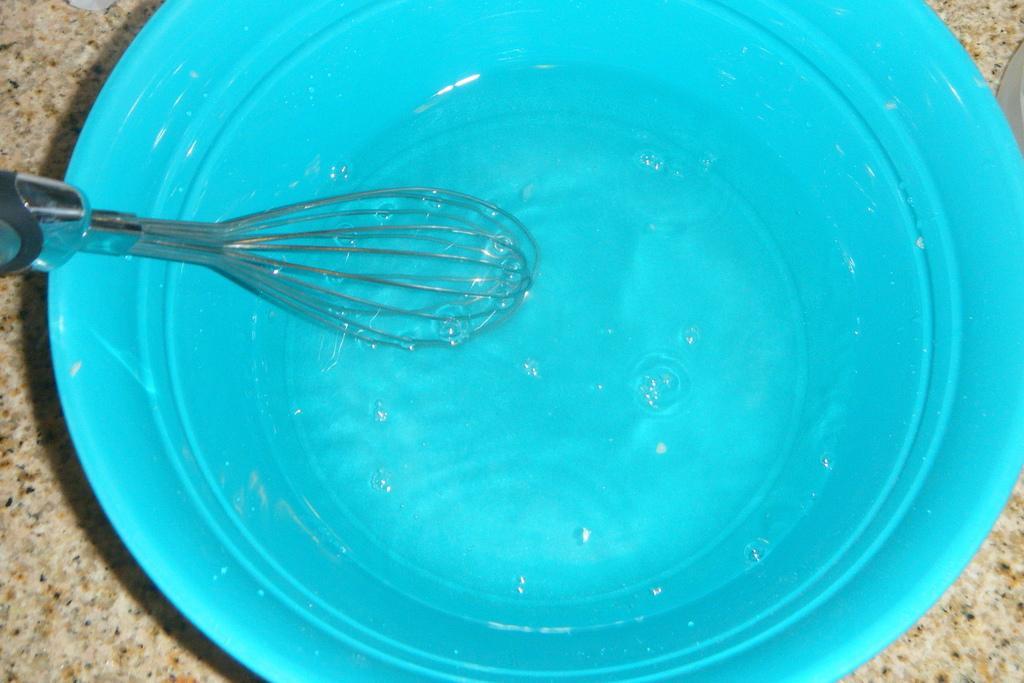In one or two sentences, can you explain what this image depicts? In this picture we can see the whisker and water in the blue bucket. This bucket is kept on the floor. On the left we can see the granite stone. 